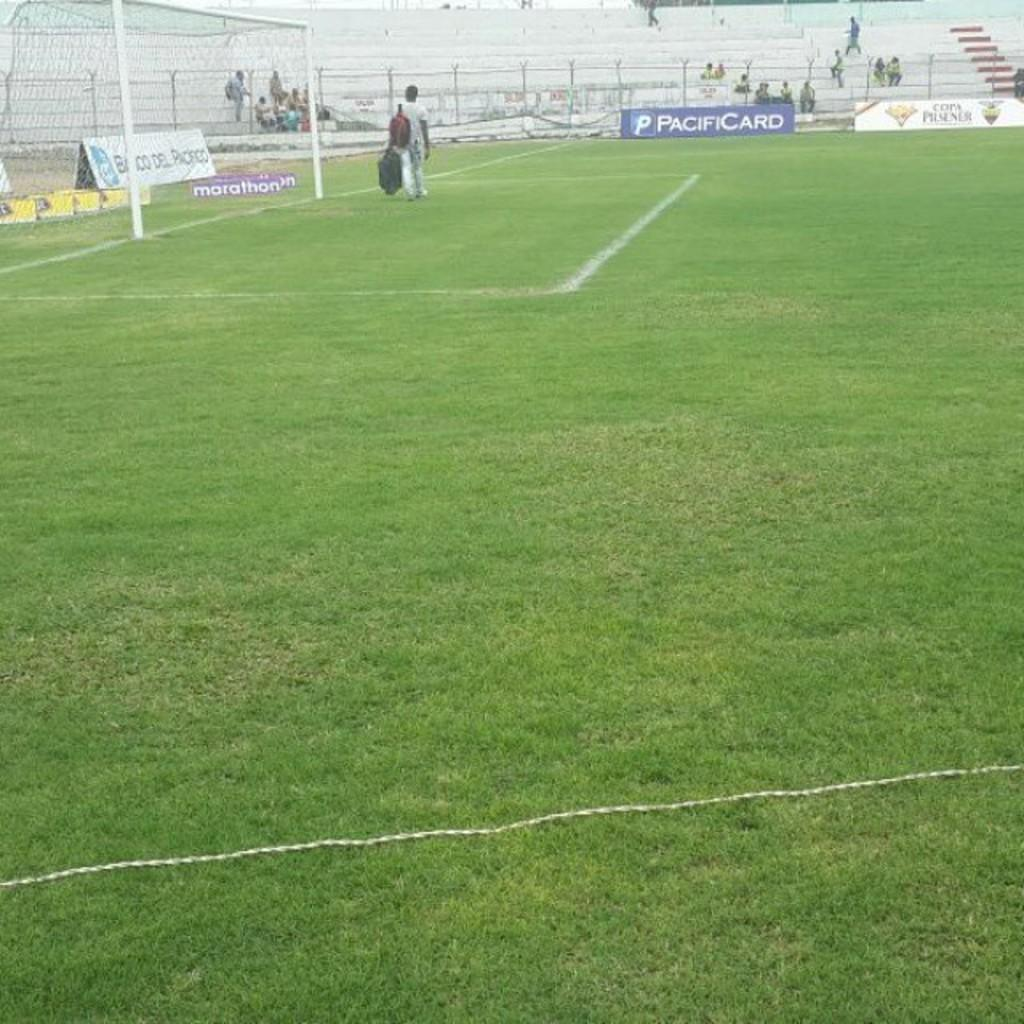<image>
Summarize the visual content of the image. A man is walking on a field with a Pacificard banner at the side of the field. 